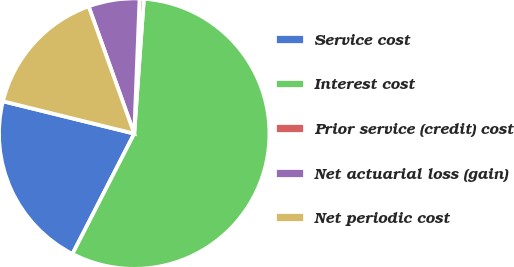Convert chart to OTSL. <chart><loc_0><loc_0><loc_500><loc_500><pie_chart><fcel>Service cost<fcel>Interest cost<fcel>Prior service (credit) cost<fcel>Net actuarial loss (gain)<fcel>Net periodic cost<nl><fcel>21.3%<fcel>56.41%<fcel>0.51%<fcel>6.1%<fcel>15.68%<nl></chart> 